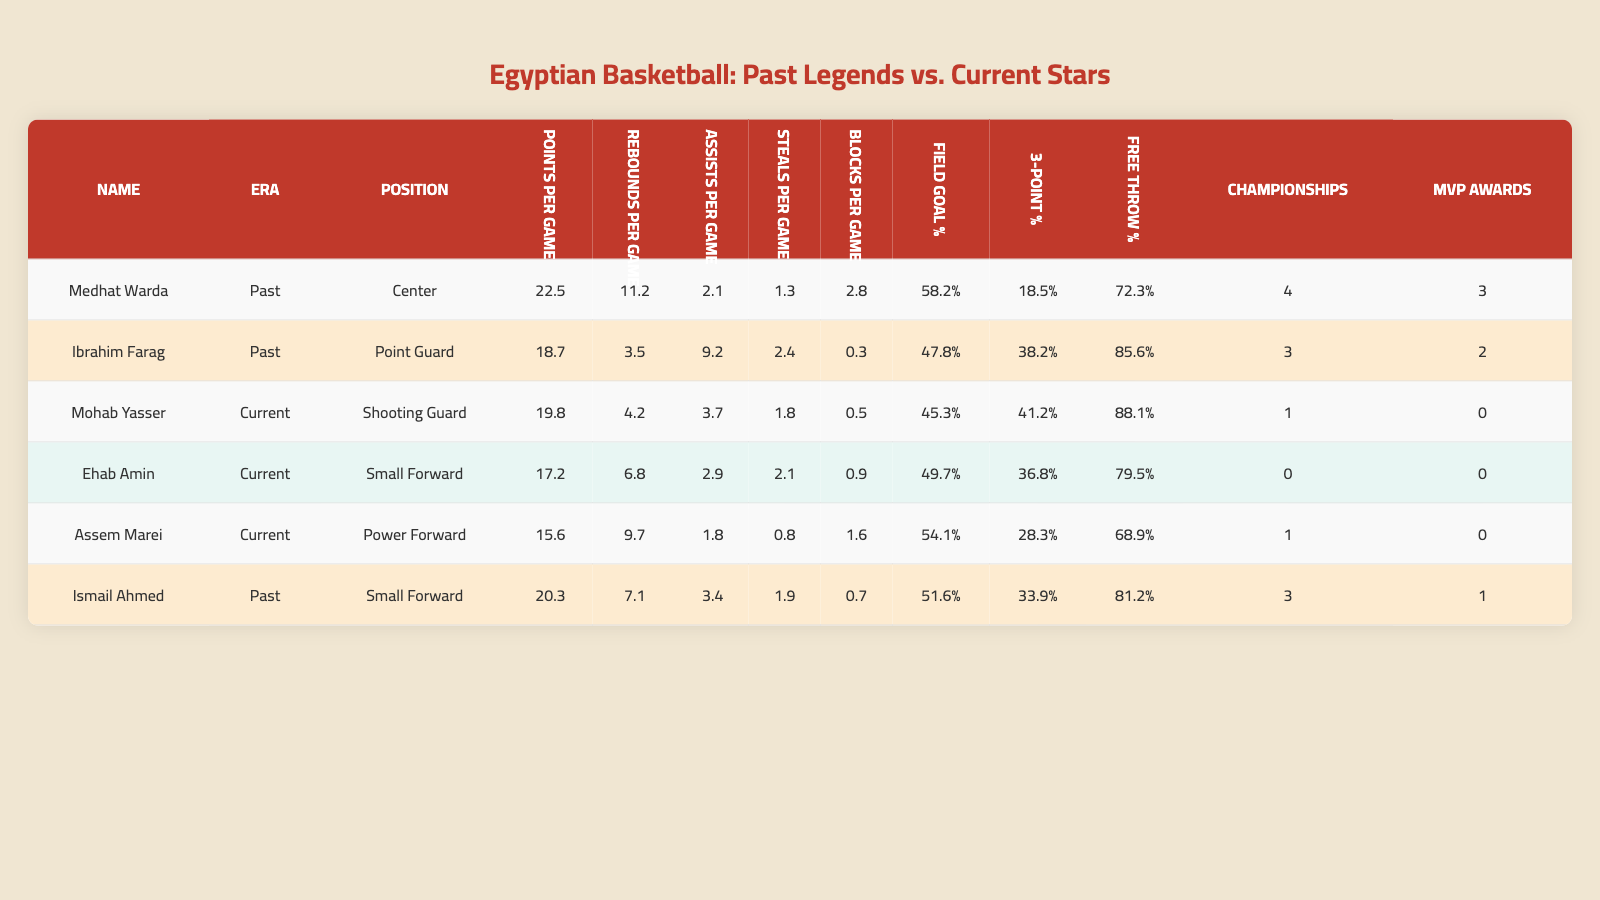What is the highest points per game average among past players? From the table, we find Medhat Warda with an average of 22.5 points per game, which is the highest among past players.
Answer: 22.5 Which current player has the highest three-point shooting percentage? Looking at the current players, Mohab Yasser has the highest three-point percentage at 41.2%.
Answer: 41.2 How many MVP awards did Ibrahim Farag win? The table shows that Ibrahim Farag won 2 MVP awards.
Answer: 2 Which player has the most championships in the current era? Both Mohab Yasser and Assem Marei have 1 championship, while past players Medhat Warda and Ismail Ahmed have more, making them the top in championships overall.
Answer: 1 Who scored more points per game, Ismail Ahmed or Ehab Amin? Ismail Ahmed scored 20.3 points per game, whereas Ehab Amin scored 17.2. Comparing these values shows Ismail scored more.
Answer: Ismail Ahmed What is the difference in free throw percentage between the best and worst current player? Mohab Yasser has the highest free throw percentage of 88.1%, while Assem Marei has the lowest at 68.9%. Thus, the difference is 88.1 - 68.9 = 19.2%.
Answer: 19.2% Did any current player achieve more than 20 points per game? By reviewing the table, Mohab Yasser scored 19.8 and Ehab Amin scored 17.2, neither reached 20 points per game.
Answer: No What is the average field goal percentage for past players? Calculating: (58.2 + 47.8 + 51.6) / 3 gives us an average of 52.53%.
Answer: 52.53 Which player had the best assists per game average in the past era? The table shows that Ibrahim Farag had the highest average assists per game in the past, with 9.2 assists.
Answer: 9.2 How many total MVP awards do past players have combined? Adding up the MVP awards from Medhat Warda (3), Ibrahim Farag (2), and Ismail Ahmed (1) gives us 6 total MVP awards.
Answer: 6 What is the combined points per game for all current players? Summing the points per game: Mohab Yasser (19.8) + Ehab Amin (17.2) + Assem Marei (15.6) gives us 52.6 total points per game combined for current players.
Answer: 52.6 